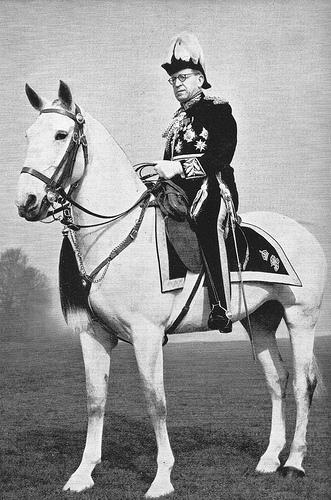Question: why is he on a horse?
Choices:
A. Taking a picture.
B. Exercising.
C. He is riding it.
D. Just sitting.
Answer with the letter. Answer: C Question: how is he dressed?
Choices:
A. T-shirt and shorts.
B. Suit.
C. In uniform.
D. Underwear.
Answer with the letter. Answer: C Question: what is he doing?
Choices:
A. Sitting on the horse.
B. Sitting on an elephant.
C. Sitting on a donkey.
D. Sitting in a chair.
Answer with the letter. Answer: A Question: what gender is the horse?
Choices:
A. Female.
B. Male.
C. Neutered.
D. Transgender.
Answer with the letter. Answer: B 